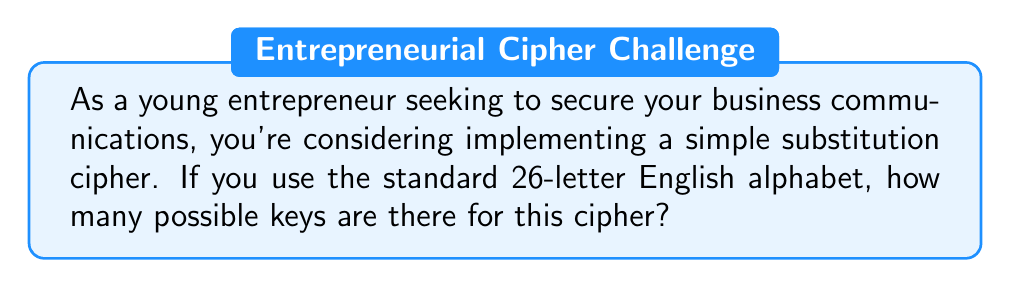Give your solution to this math problem. Let's approach this step-by-step:

1) In a simple substitution cipher, each letter of the alphabet is replaced by another letter. 

2) For the first letter, we have 26 choices.

3) For the second letter, we have 25 choices, as we can't use the letter we used for the first substitution.

4) For the third letter, we have 24 choices, and so on.

5) This continues until we reach the last letter, for which we have only 1 choice left.

6) This scenario is a perfect application of the multiplication principle in combinatorics.

7) The total number of possible keys is therefore:

   $$26 \times 25 \times 24 \times 23 \times ... \times 2 \times 1$$

8) This is the definition of 26 factorial, denoted as 26!

9) We can calculate this:

   $$26! = 403,291,461,126,605,635,584,000,000$$

This incredibly large number demonstrates why simple substitution ciphers, while easy to implement, can be secure against brute-force attacks if the message is short enough that frequency analysis is not effective.
Answer: $26!$ or 403,291,461,126,605,635,584,000,000 